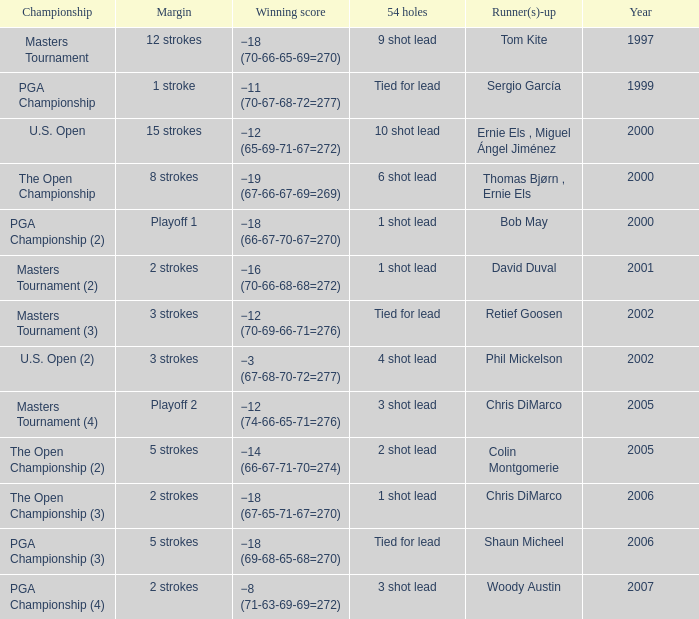 what's the 54 holes where winning score is −19 (67-66-67-69=269) 6 shot lead. 